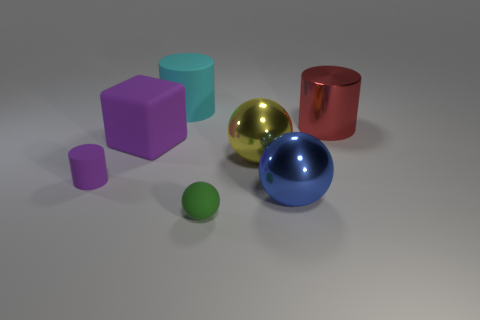Add 1 small spheres. How many objects exist? 8 Subtract all balls. How many objects are left? 4 Subtract 0 red blocks. How many objects are left? 7 Subtract all big shiny cylinders. Subtract all big things. How many objects are left? 1 Add 1 big blue shiny spheres. How many big blue shiny spheres are left? 2 Add 2 purple cylinders. How many purple cylinders exist? 3 